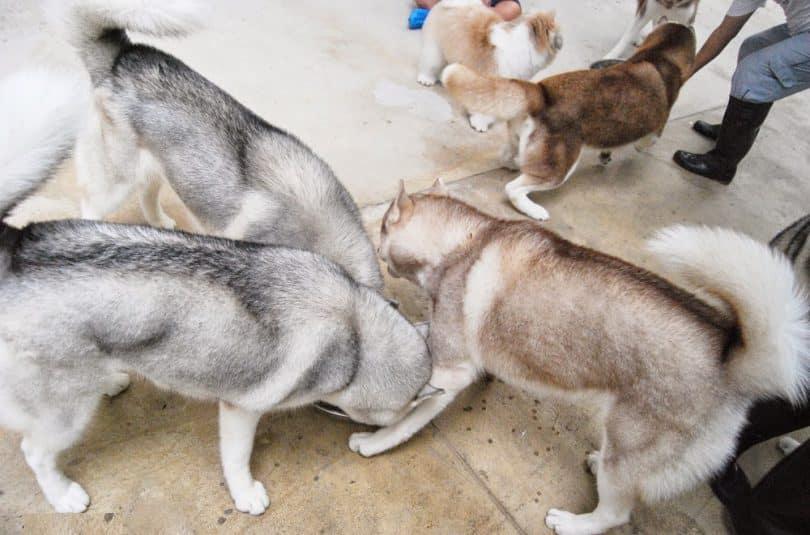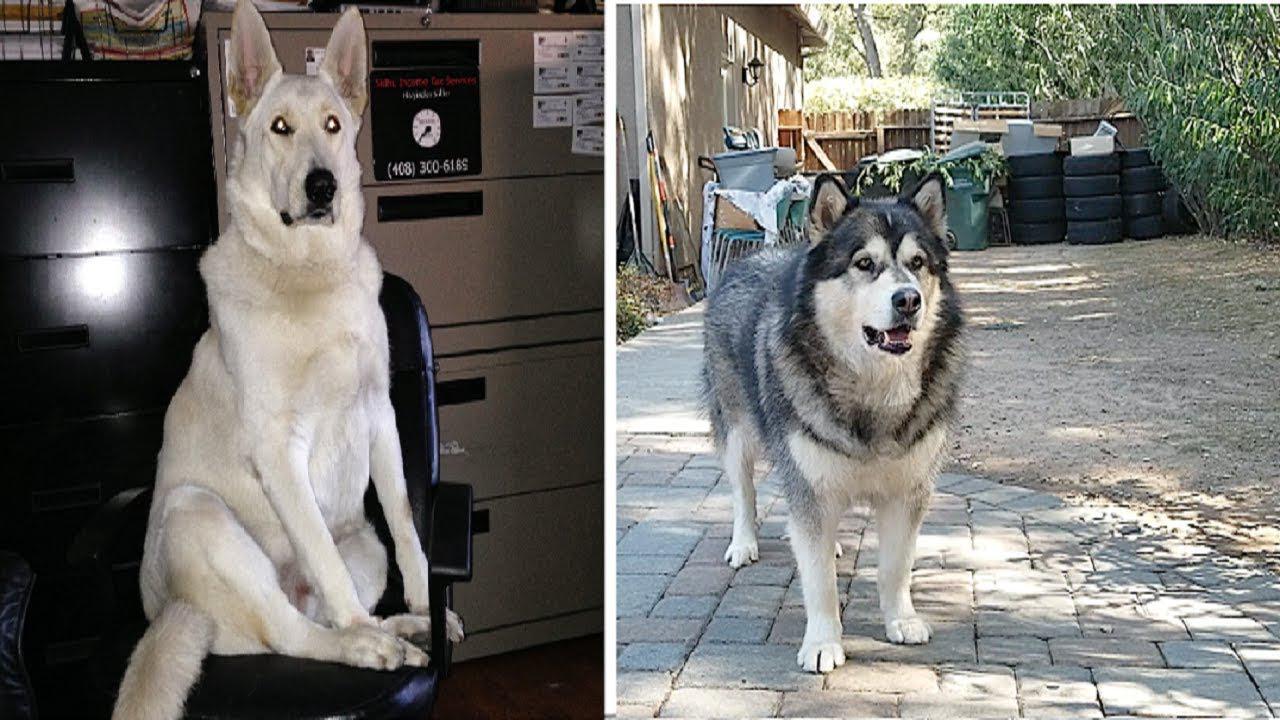The first image is the image on the left, the second image is the image on the right. Given the left and right images, does the statement "Each image contains just one dog, all dogs are black-and-white husky types, and the dog on the right is reclining with extended front paws." hold true? Answer yes or no. No. The first image is the image on the left, the second image is the image on the right. Evaluate the accuracy of this statement regarding the images: "The dog in the image on the right is indoors.". Is it true? Answer yes or no. No. 